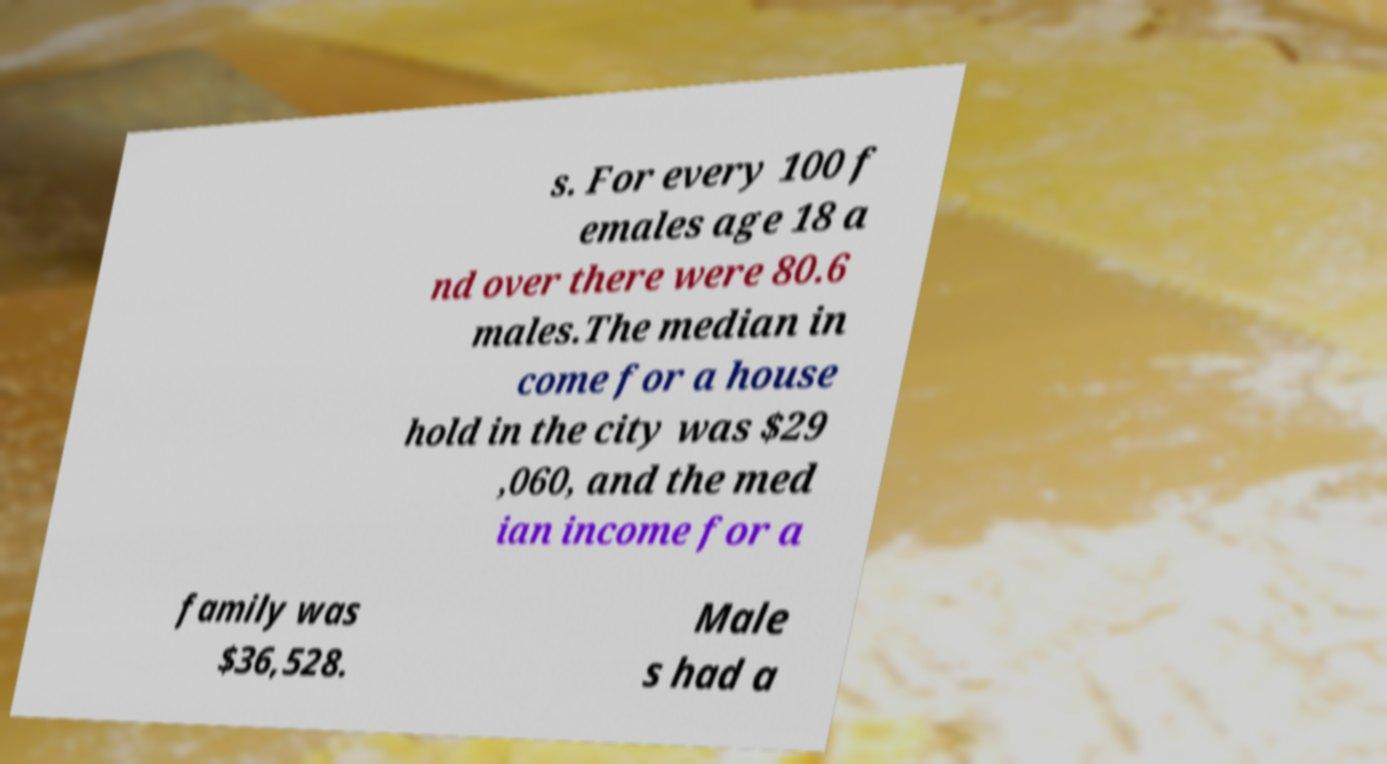Can you read and provide the text displayed in the image?This photo seems to have some interesting text. Can you extract and type it out for me? s. For every 100 f emales age 18 a nd over there were 80.6 males.The median in come for a house hold in the city was $29 ,060, and the med ian income for a family was $36,528. Male s had a 